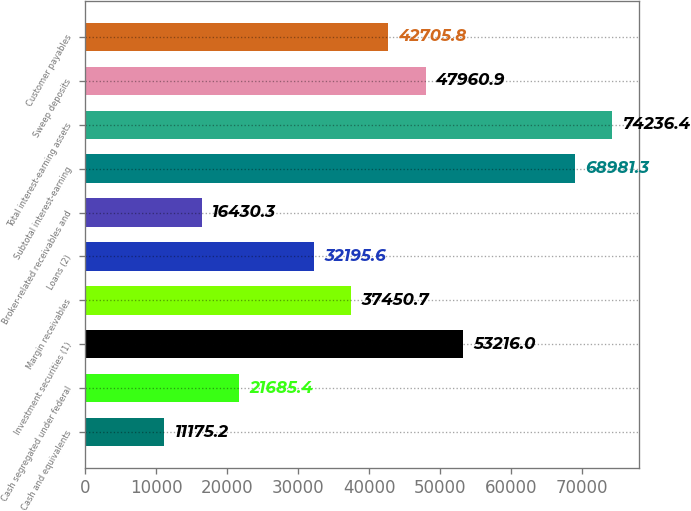Convert chart. <chart><loc_0><loc_0><loc_500><loc_500><bar_chart><fcel>Cash and equivalents<fcel>Cash segregated under federal<fcel>Investment securities (1)<fcel>Margin receivables<fcel>Loans (2)<fcel>Broker-related receivables and<fcel>Subtotal interest-earning<fcel>Total interest-earning assets<fcel>Sweep deposits<fcel>Customer payables<nl><fcel>11175.2<fcel>21685.4<fcel>53216<fcel>37450.7<fcel>32195.6<fcel>16430.3<fcel>68981.3<fcel>74236.4<fcel>47960.9<fcel>42705.8<nl></chart> 